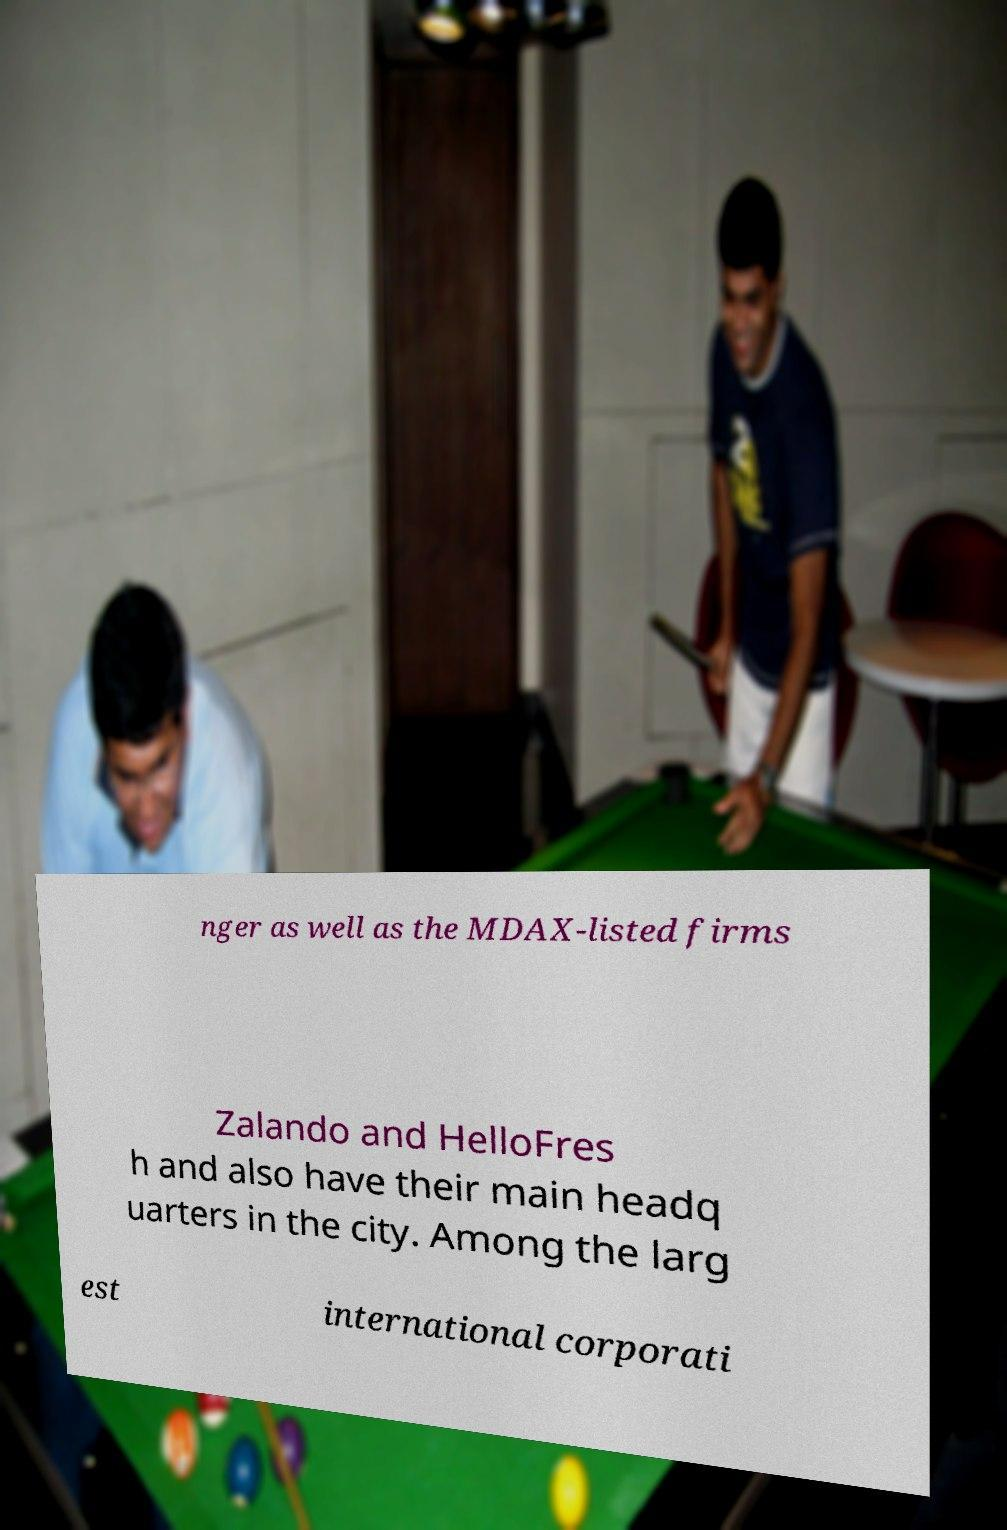Can you read and provide the text displayed in the image?This photo seems to have some interesting text. Can you extract and type it out for me? nger as well as the MDAX-listed firms Zalando and HelloFres h and also have their main headq uarters in the city. Among the larg est international corporati 